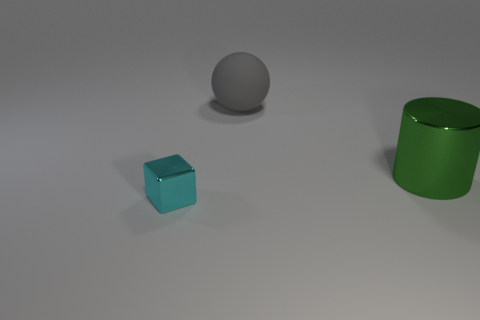Add 2 green metal cylinders. How many objects exist? 5 Subtract all blocks. How many objects are left? 2 Add 1 cyan metallic blocks. How many cyan metallic blocks are left? 2 Add 1 yellow cylinders. How many yellow cylinders exist? 1 Subtract 0 gray cubes. How many objects are left? 3 Subtract all green metallic cylinders. Subtract all balls. How many objects are left? 1 